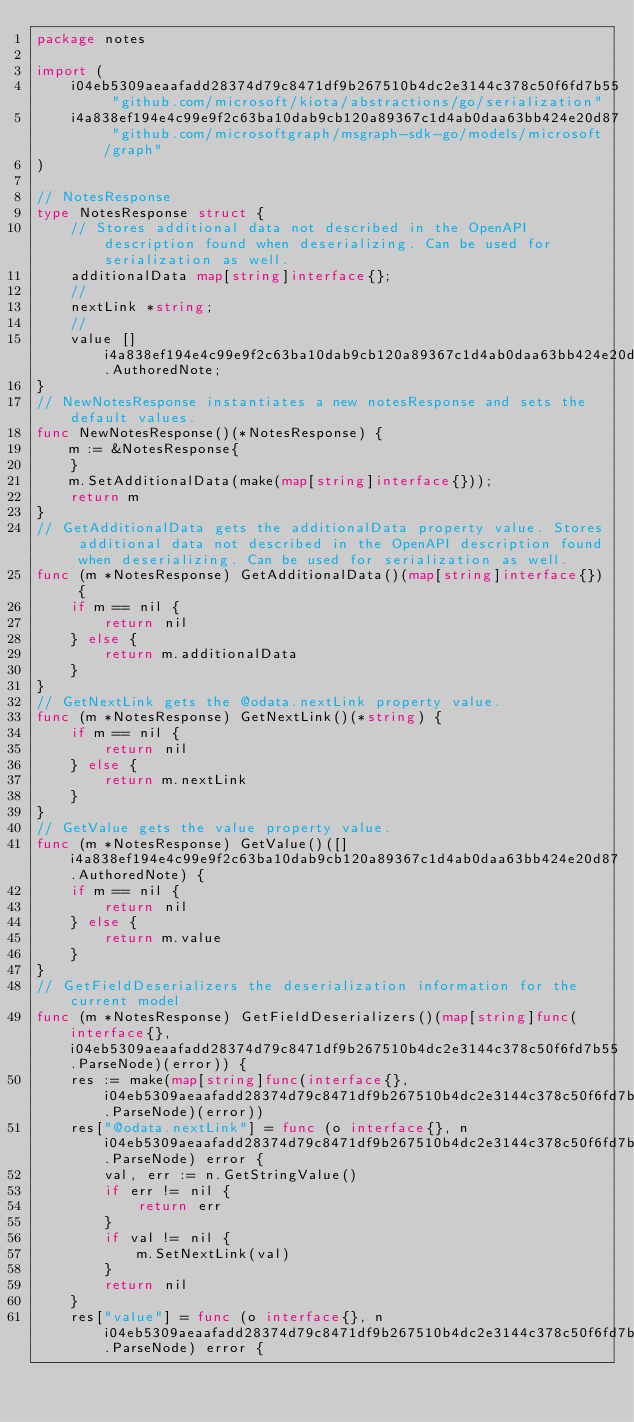Convert code to text. <code><loc_0><loc_0><loc_500><loc_500><_Go_>package notes

import (
    i04eb5309aeaafadd28374d79c8471df9b267510b4dc2e3144c378c50f6fd7b55 "github.com/microsoft/kiota/abstractions/go/serialization"
    i4a838ef194e4c99e9f2c63ba10dab9cb120a89367c1d4ab0daa63bb424e20d87 "github.com/microsoftgraph/msgraph-sdk-go/models/microsoft/graph"
)

// NotesResponse 
type NotesResponse struct {
    // Stores additional data not described in the OpenAPI description found when deserializing. Can be used for serialization as well.
    additionalData map[string]interface{};
    // 
    nextLink *string;
    // 
    value []i4a838ef194e4c99e9f2c63ba10dab9cb120a89367c1d4ab0daa63bb424e20d87.AuthoredNote;
}
// NewNotesResponse instantiates a new notesResponse and sets the default values.
func NewNotesResponse()(*NotesResponse) {
    m := &NotesResponse{
    }
    m.SetAdditionalData(make(map[string]interface{}));
    return m
}
// GetAdditionalData gets the additionalData property value. Stores additional data not described in the OpenAPI description found when deserializing. Can be used for serialization as well.
func (m *NotesResponse) GetAdditionalData()(map[string]interface{}) {
    if m == nil {
        return nil
    } else {
        return m.additionalData
    }
}
// GetNextLink gets the @odata.nextLink property value. 
func (m *NotesResponse) GetNextLink()(*string) {
    if m == nil {
        return nil
    } else {
        return m.nextLink
    }
}
// GetValue gets the value property value. 
func (m *NotesResponse) GetValue()([]i4a838ef194e4c99e9f2c63ba10dab9cb120a89367c1d4ab0daa63bb424e20d87.AuthoredNote) {
    if m == nil {
        return nil
    } else {
        return m.value
    }
}
// GetFieldDeserializers the deserialization information for the current model
func (m *NotesResponse) GetFieldDeserializers()(map[string]func(interface{}, i04eb5309aeaafadd28374d79c8471df9b267510b4dc2e3144c378c50f6fd7b55.ParseNode)(error)) {
    res := make(map[string]func(interface{}, i04eb5309aeaafadd28374d79c8471df9b267510b4dc2e3144c378c50f6fd7b55.ParseNode)(error))
    res["@odata.nextLink"] = func (o interface{}, n i04eb5309aeaafadd28374d79c8471df9b267510b4dc2e3144c378c50f6fd7b55.ParseNode) error {
        val, err := n.GetStringValue()
        if err != nil {
            return err
        }
        if val != nil {
            m.SetNextLink(val)
        }
        return nil
    }
    res["value"] = func (o interface{}, n i04eb5309aeaafadd28374d79c8471df9b267510b4dc2e3144c378c50f6fd7b55.ParseNode) error {</code> 